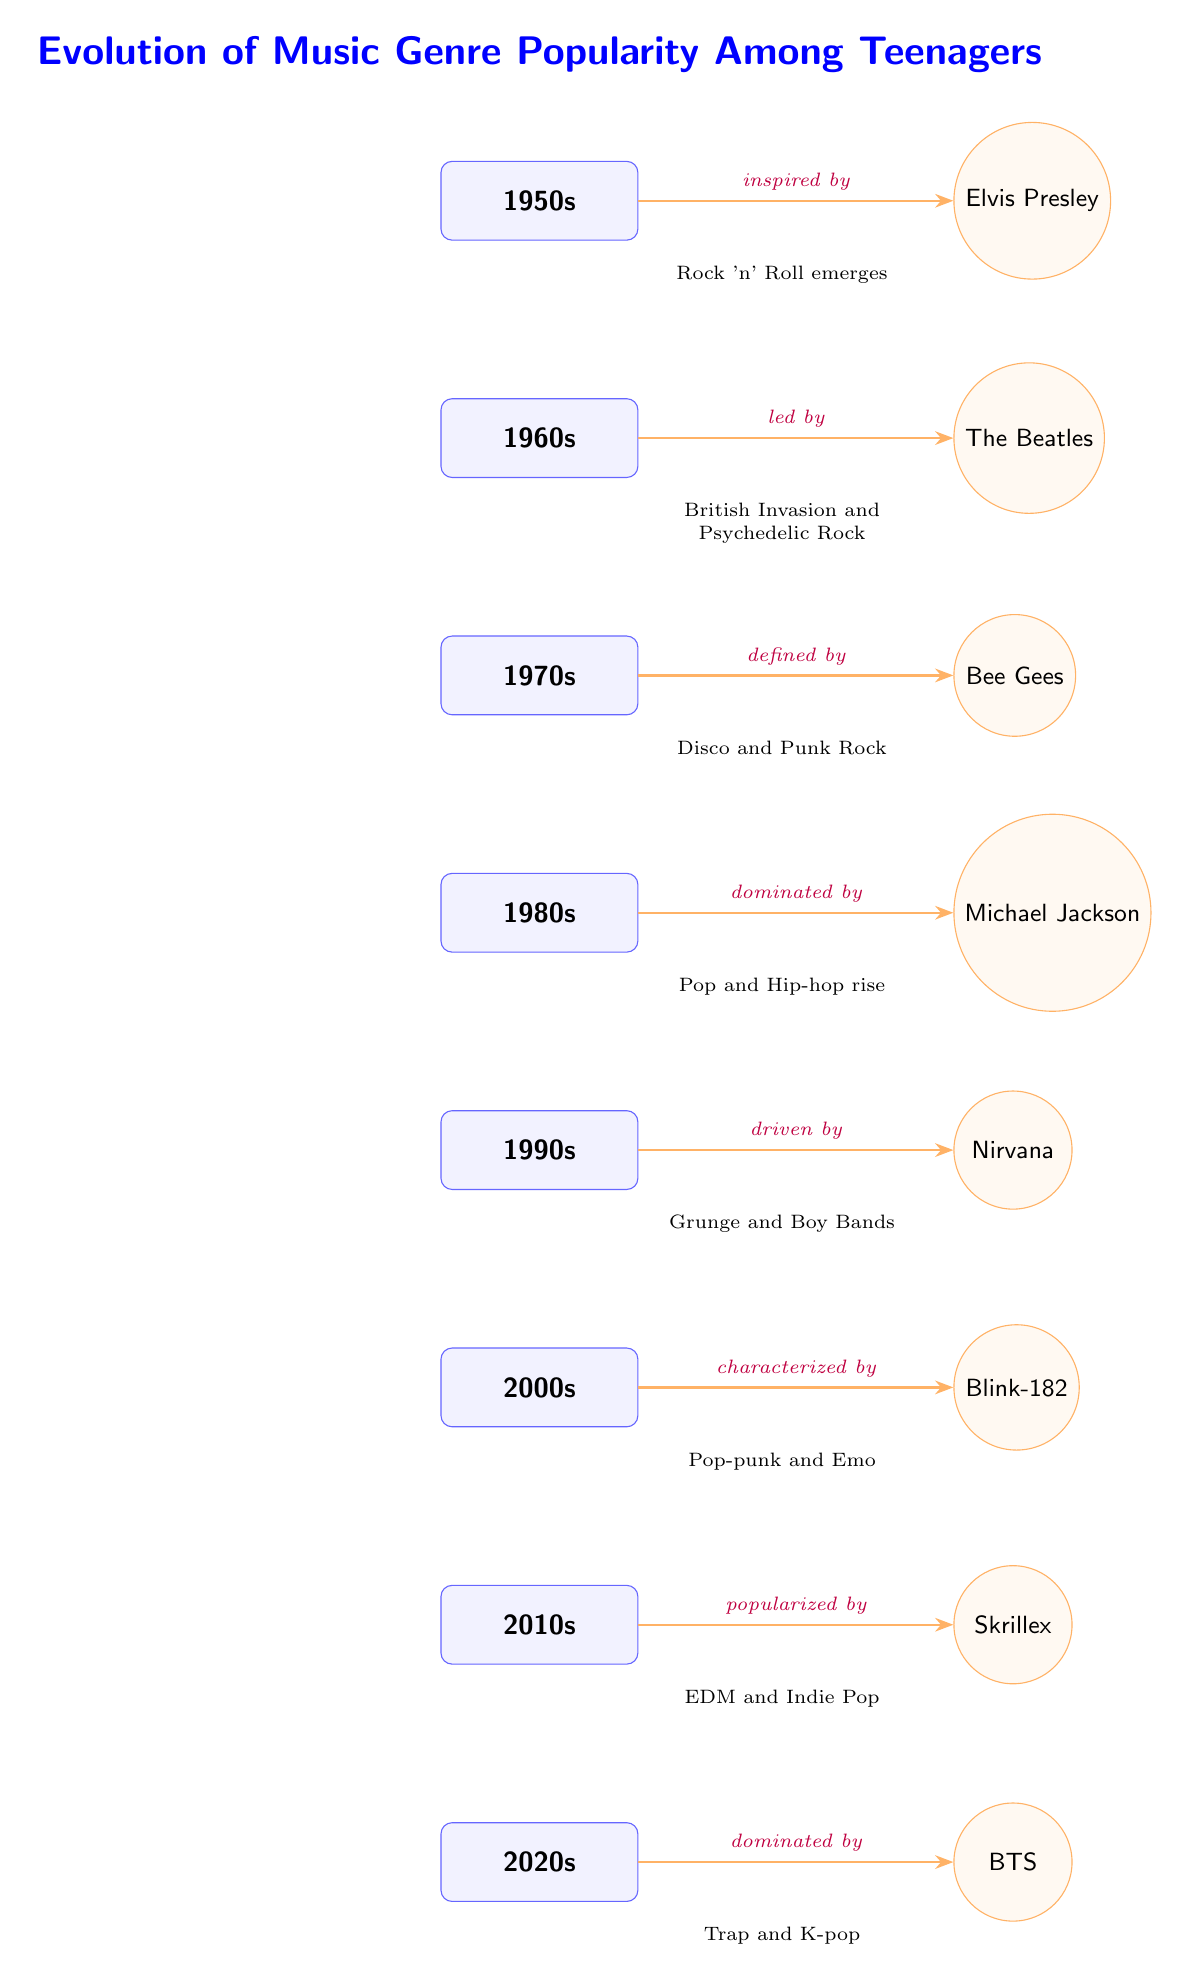What genre emerged in the 1950s? The diagram indicates that Rock 'n' Roll emerged in the 1950s as part of the evolution of music genre popularity among teenagers.
Answer: Rock 'n' Roll Who popularized music in the 2010s? According to the connections in the diagram, Skrillex is noted as the key figure who popularized music in the 2010s.
Answer: Skrillex What decade is characterized by Disco and Punk Rock? By examining the descriptions under each decade node, it shows that the 1970s is defined by Disco and Punk Rock.
Answer: 1970s How many decades are represented in the diagram? The diagram has a total of 8 decades, ranging from the 1950s to the 2020s, each represented by a node.
Answer: 8 Which band is associated with the 1990s? Based on the diagram’s labels, Nirvana is the band identified for the 1990s, indicated by the arrow leading to it.
Answer: Nirvana What genre is linked to the iconic figure Michael Jackson? The diagram specifies that the 1980s was dominated by Michael Jackson, which indicates the genre connected to him is Pop and Hip-hop.
Answer: Pop and Hip-hop Which decade shows a trend towards K-pop? The diagram indicates that the 2020s is dominated by BTS, which is associated with the rise of K-pop as a significant genre during this decade.
Answer: 2020s What key influence is noted in the 2000s? Referencing the diagram, Blink-182 is highlighted as the defining influence in the 2000s, characterizing the predominant music trend of that decade.
Answer: Blink-182 What genre characterized the 2010s? The diagram illustrates that the 2010s is characterized by EDM and Indie Pop, as shown in the description next to the corresponding decade node.
Answer: EDM and Indie Pop 